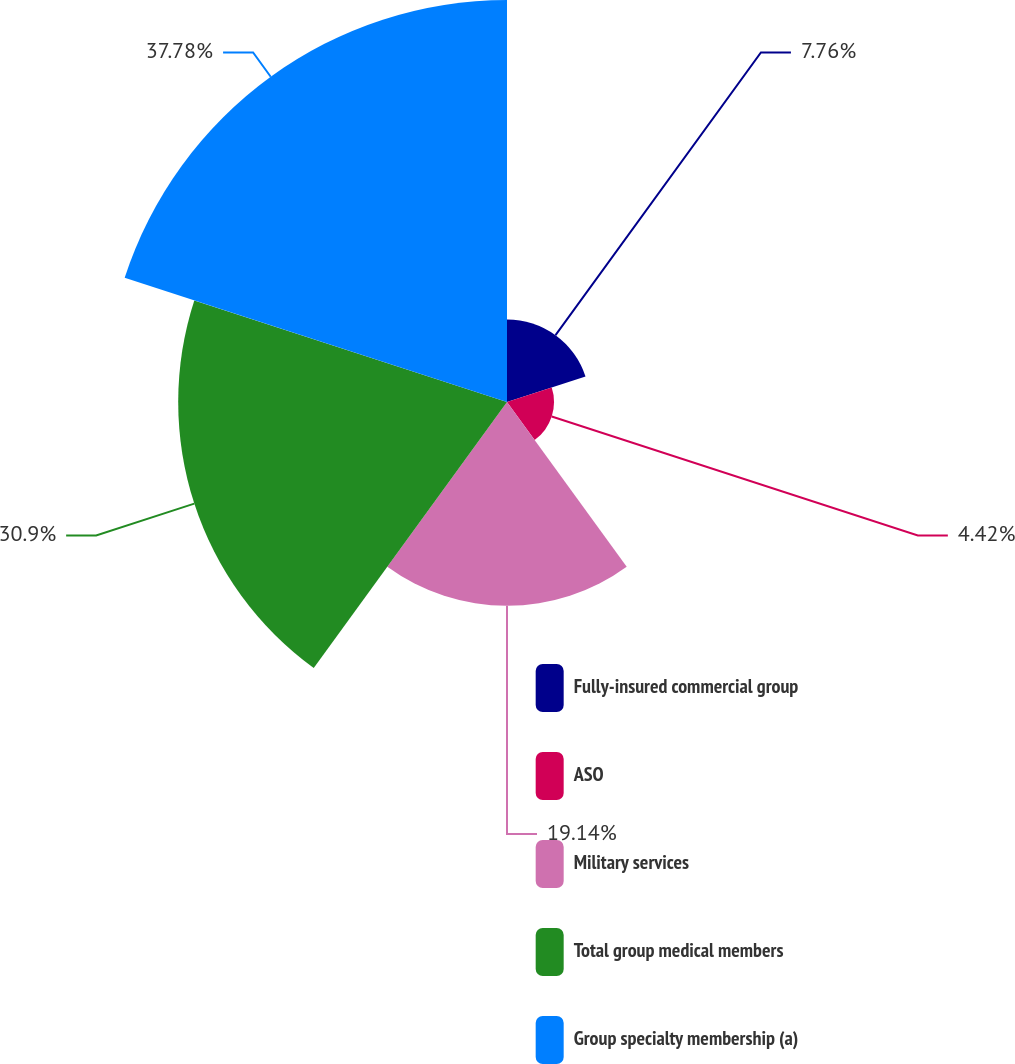Convert chart. <chart><loc_0><loc_0><loc_500><loc_500><pie_chart><fcel>Fully-insured commercial group<fcel>ASO<fcel>Military services<fcel>Total group medical members<fcel>Group specialty membership (a)<nl><fcel>7.76%<fcel>4.42%<fcel>19.14%<fcel>30.9%<fcel>37.78%<nl></chart> 